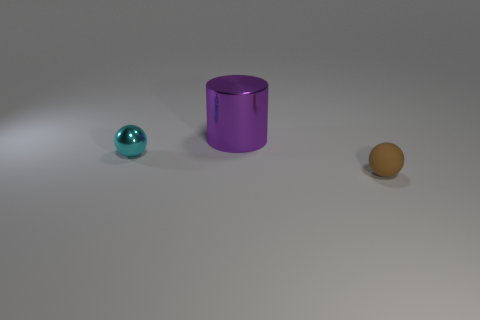Do the sphere that is left of the rubber thing and the big metallic object have the same color?
Make the answer very short. No. How many blue things are either small shiny objects or rubber spheres?
Offer a terse response. 0. What number of other objects are there of the same shape as the brown object?
Make the answer very short. 1. Are the cylinder and the small brown ball made of the same material?
Your response must be concise. No. What is the material of the thing that is in front of the big purple cylinder and on the left side of the tiny brown sphere?
Your answer should be very brief. Metal. The small object left of the brown rubber thing is what color?
Provide a short and direct response. Cyan. Is the number of small shiny objects that are behind the large metallic cylinder greater than the number of green matte spheres?
Make the answer very short. No. What number of other things are there of the same size as the purple cylinder?
Provide a succinct answer. 0. How many small things are behind the metallic cylinder?
Offer a very short reply. 0. Are there an equal number of tiny cyan metallic balls on the right side of the big purple cylinder and tiny cyan shiny objects that are in front of the matte ball?
Your answer should be very brief. Yes. 